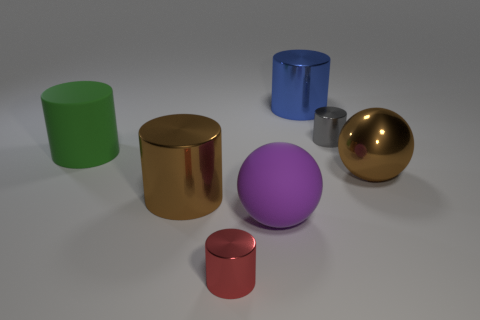Is the color of the large shiny cylinder that is in front of the large green rubber thing the same as the big ball that is behind the purple object?
Give a very brief answer. Yes. There is a cylinder that is the same color as the large shiny ball; what material is it?
Your answer should be compact. Metal. How many other objects are there of the same color as the shiny sphere?
Your response must be concise. 1. What is the color of the sphere that is on the left side of the tiny gray cylinder?
Provide a succinct answer. Purple. What number of objects are large spheres that are on the right side of the blue shiny cylinder or rubber things to the left of the brown cylinder?
Your response must be concise. 2. Is the size of the red cylinder the same as the brown ball?
Provide a succinct answer. No. How many blocks are metallic objects or large metal things?
Provide a succinct answer. 0. How many tiny things are both behind the large shiny ball and in front of the big green rubber cylinder?
Your response must be concise. 0. There is a gray object; does it have the same size as the thing that is in front of the purple matte object?
Keep it short and to the point. Yes. There is a brown object that is on the left side of the big brown metal object on the right side of the red cylinder; is there a large matte thing that is right of it?
Make the answer very short. Yes. 